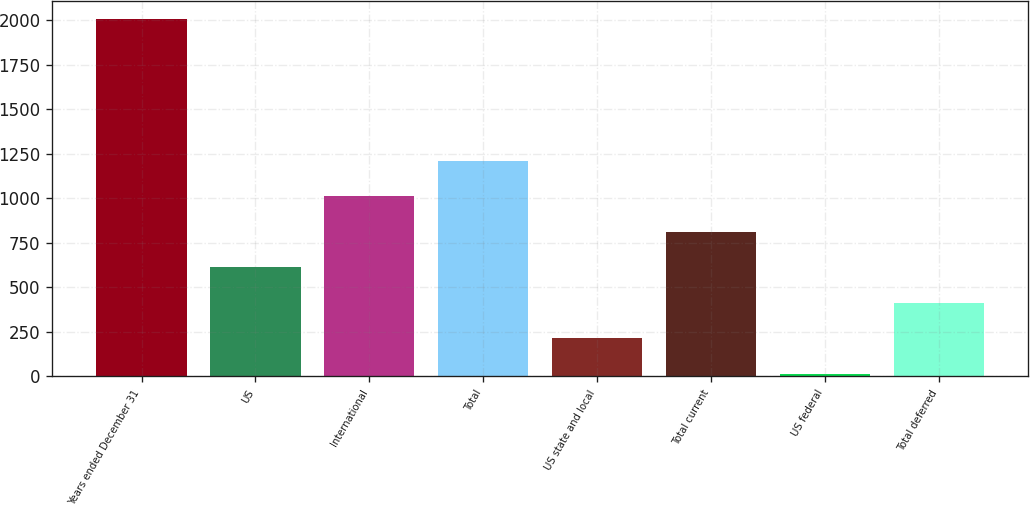Convert chart to OTSL. <chart><loc_0><loc_0><loc_500><loc_500><bar_chart><fcel>Years ended December 31<fcel>US<fcel>International<fcel>Total<fcel>US state and local<fcel>Total current<fcel>US federal<fcel>Total deferred<nl><fcel>2008<fcel>612.9<fcel>1011.5<fcel>1210.8<fcel>214.3<fcel>812.2<fcel>15<fcel>413.6<nl></chart> 